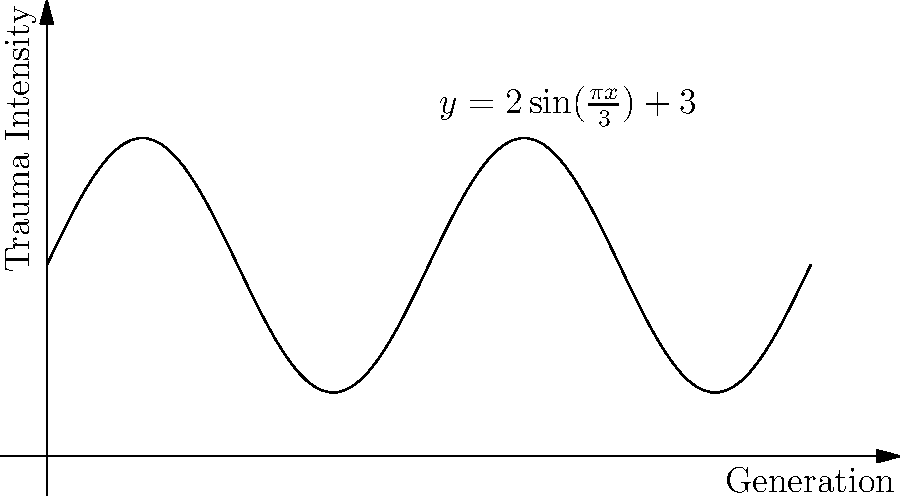In a study on intergenerational trauma, a filmmaker discovers a cyclical pattern represented by the sine function $y = 2\sin(\frac{\pi x}{3}) + 3$, where $y$ is the trauma intensity and $x$ represents generations. What is the period of this function, indicating how many generations it takes for the trauma pattern to complete one full cycle? To find the period of the sine function, we need to follow these steps:

1) The general form of a sine function is:
   $y = A\sin(B(x - C)) + D$

2) In our case, $y = 2\sin(\frac{\pi x}{3}) + 3$
   So, $A = 2$, $B = \frac{\pi}{3}$, $C = 0$, and $D = 3$

3) The period of a sine function is given by the formula:
   $\text{Period} = \frac{2\pi}{|B|}$

4) Substituting our $B$ value:
   $\text{Period} = \frac{2\pi}{|\frac{\pi}{3}|}$

5) Simplify:
   $\text{Period} = \frac{2\pi}{\frac{\pi}{3}} = 2 \cdot 3 = 6$

Therefore, the period of the function is 6, meaning the trauma pattern completes one full cycle every 6 generations.
Answer: 6 generations 